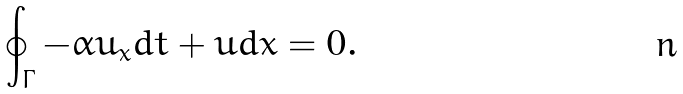Convert formula to latex. <formula><loc_0><loc_0><loc_500><loc_500>\oint _ { \Gamma } - \alpha u _ { x } d t + u d x = 0 .</formula> 